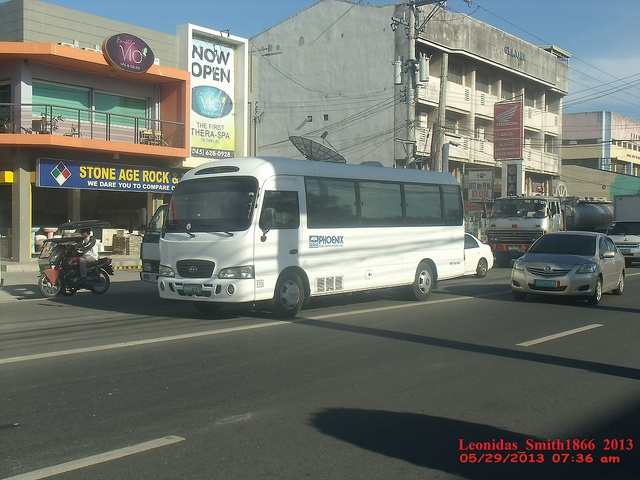Describe the objects in this image and their specific colors. I can see bus in gray, ivory, and darkgray tones, car in gray, black, blue, and darkgray tones, truck in gray, black, purple, and darkgray tones, motorcycle in gray, black, brown, and purple tones, and truck in gray, black, darkgray, and purple tones in this image. 